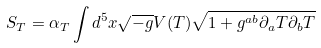<formula> <loc_0><loc_0><loc_500><loc_500>S _ { T } = \alpha _ { T } \int d ^ { 5 } x \sqrt { - g } V ( T ) \sqrt { 1 + g ^ { a b } \partial _ { a } T \partial _ { b } T }</formula> 